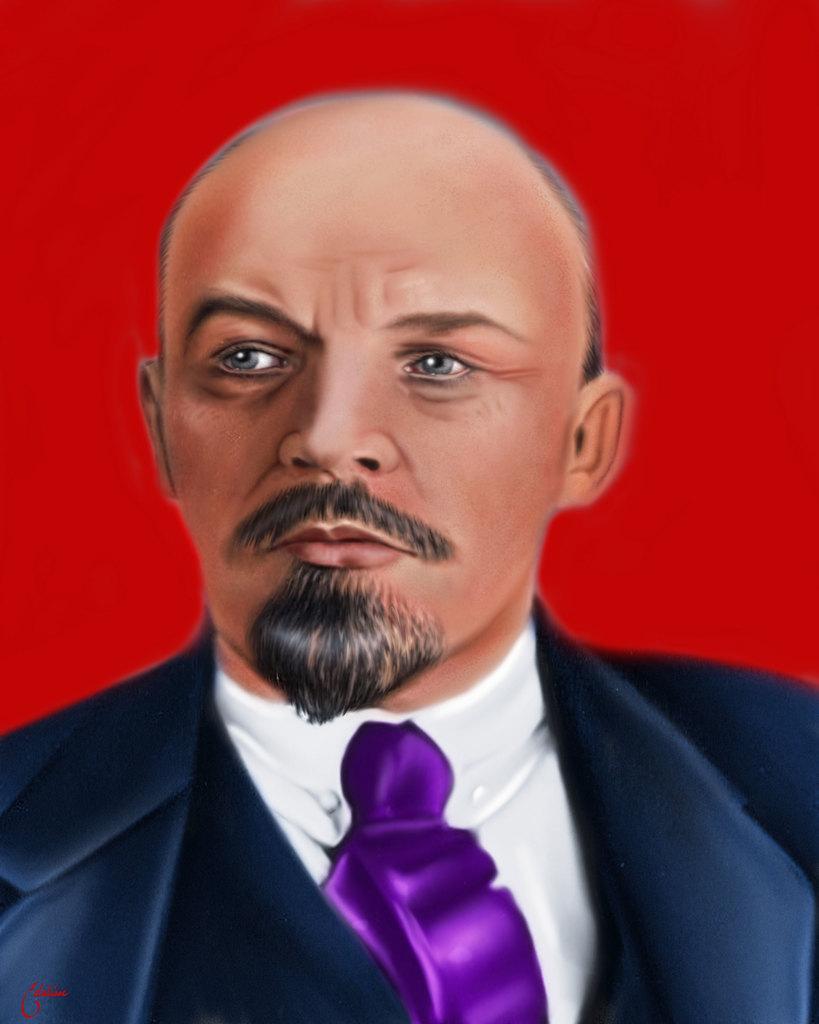Describe this image in one or two sentences. In this image we can see a person wearing a suit and also we can see the red color background. 